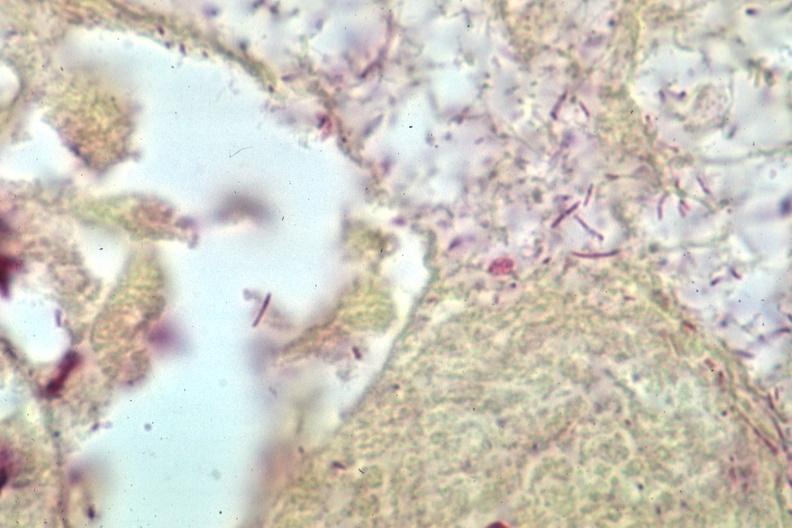s meningitis purulent present?
Answer the question using a single word or phrase. Yes 